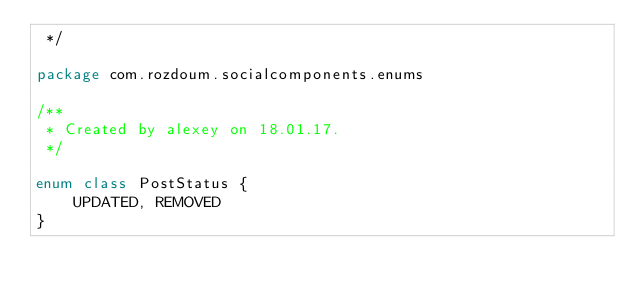<code> <loc_0><loc_0><loc_500><loc_500><_Kotlin_> */

package com.rozdoum.socialcomponents.enums

/**
 * Created by alexey on 18.01.17.
 */

enum class PostStatus {
    UPDATED, REMOVED
}
</code> 